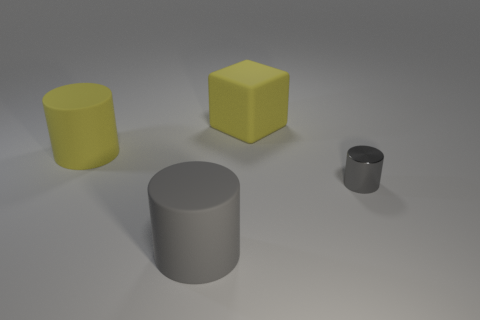Subtract all large gray cylinders. How many cylinders are left? 2 Subtract all purple balls. How many gray cylinders are left? 2 Subtract all yellow cylinders. How many cylinders are left? 2 Subtract 1 cylinders. How many cylinders are left? 2 Subtract all blocks. How many objects are left? 3 Add 2 large things. How many objects exist? 6 Subtract all green cylinders. Subtract all red cubes. How many cylinders are left? 3 Subtract all matte objects. Subtract all blue matte blocks. How many objects are left? 1 Add 2 tiny shiny cylinders. How many tiny shiny cylinders are left? 3 Add 4 tiny gray rubber cubes. How many tiny gray rubber cubes exist? 4 